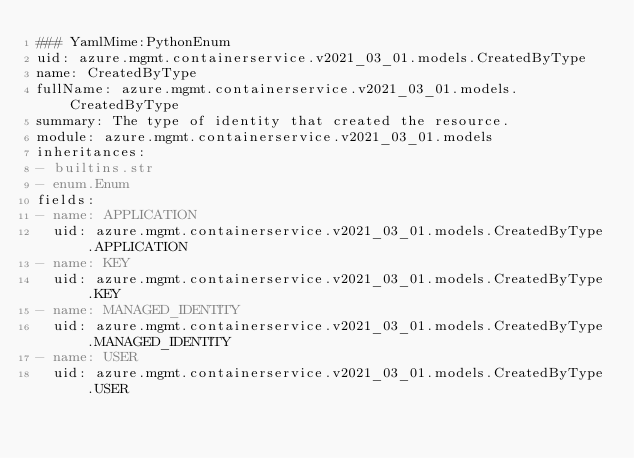<code> <loc_0><loc_0><loc_500><loc_500><_YAML_>### YamlMime:PythonEnum
uid: azure.mgmt.containerservice.v2021_03_01.models.CreatedByType
name: CreatedByType
fullName: azure.mgmt.containerservice.v2021_03_01.models.CreatedByType
summary: The type of identity that created the resource.
module: azure.mgmt.containerservice.v2021_03_01.models
inheritances:
- builtins.str
- enum.Enum
fields:
- name: APPLICATION
  uid: azure.mgmt.containerservice.v2021_03_01.models.CreatedByType.APPLICATION
- name: KEY
  uid: azure.mgmt.containerservice.v2021_03_01.models.CreatedByType.KEY
- name: MANAGED_IDENTITY
  uid: azure.mgmt.containerservice.v2021_03_01.models.CreatedByType.MANAGED_IDENTITY
- name: USER
  uid: azure.mgmt.containerservice.v2021_03_01.models.CreatedByType.USER
</code> 